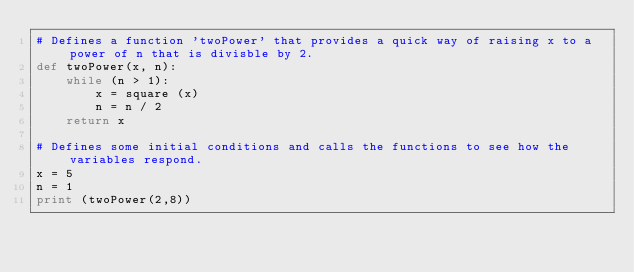Convert code to text. <code><loc_0><loc_0><loc_500><loc_500><_Python_># Defines a function 'twoPower' that provides a quick way of raising x to a power of n that is divisble by 2.
def twoPower(x, n):
    while (n > 1):
        x = square (x)
        n = n / 2
    return x

# Defines some initial conditions and calls the functions to see how the variables respond.
x = 5
n = 1
print (twoPower(2,8))</code> 